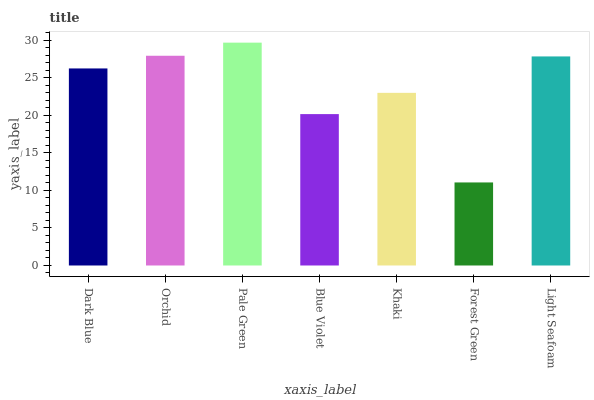Is Forest Green the minimum?
Answer yes or no. Yes. Is Pale Green the maximum?
Answer yes or no. Yes. Is Orchid the minimum?
Answer yes or no. No. Is Orchid the maximum?
Answer yes or no. No. Is Orchid greater than Dark Blue?
Answer yes or no. Yes. Is Dark Blue less than Orchid?
Answer yes or no. Yes. Is Dark Blue greater than Orchid?
Answer yes or no. No. Is Orchid less than Dark Blue?
Answer yes or no. No. Is Dark Blue the high median?
Answer yes or no. Yes. Is Dark Blue the low median?
Answer yes or no. Yes. Is Blue Violet the high median?
Answer yes or no. No. Is Orchid the low median?
Answer yes or no. No. 